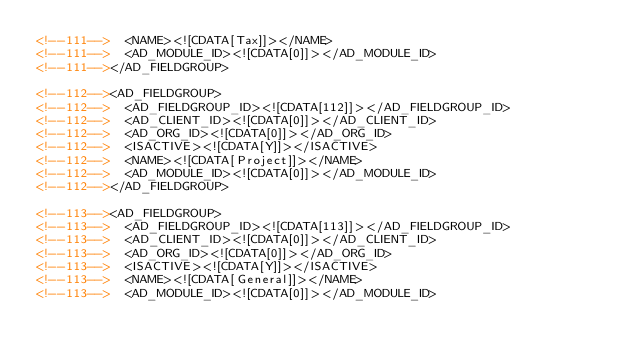<code> <loc_0><loc_0><loc_500><loc_500><_XML_><!--111-->  <NAME><![CDATA[Tax]]></NAME>
<!--111-->  <AD_MODULE_ID><![CDATA[0]]></AD_MODULE_ID>
<!--111--></AD_FIELDGROUP>

<!--112--><AD_FIELDGROUP>
<!--112-->  <AD_FIELDGROUP_ID><![CDATA[112]]></AD_FIELDGROUP_ID>
<!--112-->  <AD_CLIENT_ID><![CDATA[0]]></AD_CLIENT_ID>
<!--112-->  <AD_ORG_ID><![CDATA[0]]></AD_ORG_ID>
<!--112-->  <ISACTIVE><![CDATA[Y]]></ISACTIVE>
<!--112-->  <NAME><![CDATA[Project]]></NAME>
<!--112-->  <AD_MODULE_ID><![CDATA[0]]></AD_MODULE_ID>
<!--112--></AD_FIELDGROUP>

<!--113--><AD_FIELDGROUP>
<!--113-->  <AD_FIELDGROUP_ID><![CDATA[113]]></AD_FIELDGROUP_ID>
<!--113-->  <AD_CLIENT_ID><![CDATA[0]]></AD_CLIENT_ID>
<!--113-->  <AD_ORG_ID><![CDATA[0]]></AD_ORG_ID>
<!--113-->  <ISACTIVE><![CDATA[Y]]></ISACTIVE>
<!--113-->  <NAME><![CDATA[General]]></NAME>
<!--113-->  <AD_MODULE_ID><![CDATA[0]]></AD_MODULE_ID></code> 